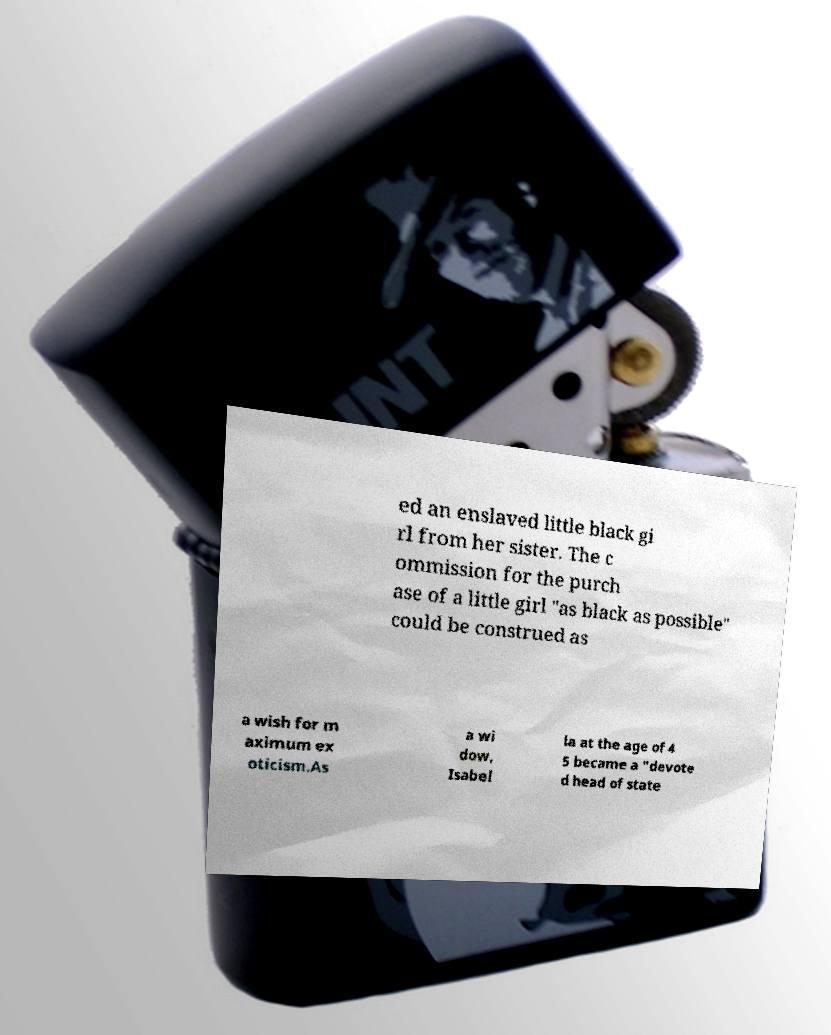Please read and relay the text visible in this image. What does it say? ed an enslaved little black gi rl from her sister. The c ommission for the purch ase of a little girl "as black as possible" could be construed as a wish for m aximum ex oticism.As a wi dow, Isabel la at the age of 4 5 became a "devote d head of state 